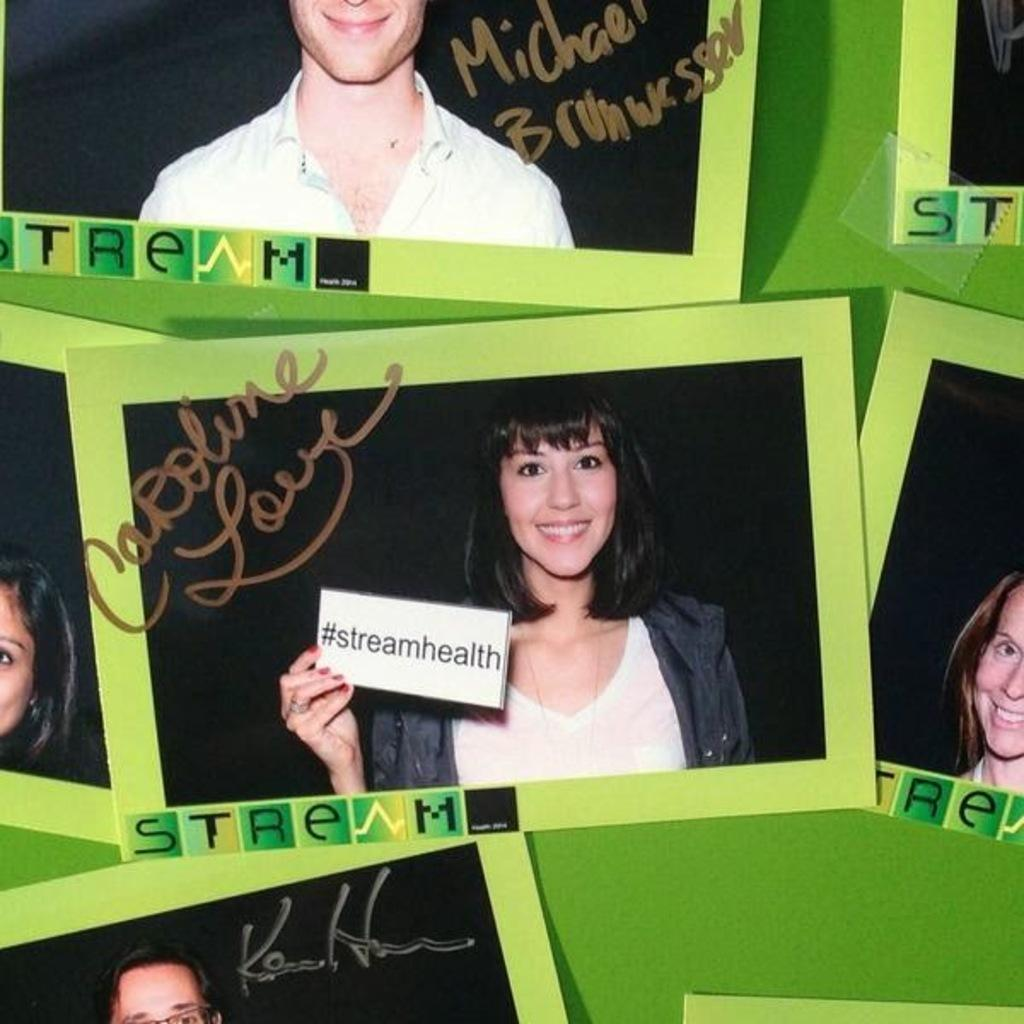What is the color of the surface in the image? The surface in the image is green. What objects are present on the green surface? There are photo frames on the green surface. What can be seen on the photo frames? There is writing on the photo frames. How many kittens are playing with a cub on the green surface in the image? There are no kittens or cubs present in the image; it only features photo frames with writing on them. What type of pancake is being served on the green surface in the image? There is no pancake present in the image; it only features photo frames with writing on them. 